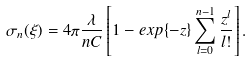Convert formula to latex. <formula><loc_0><loc_0><loc_500><loc_500>\sigma _ { n } ( \xi ) = 4 \pi \frac { \lambda } { n C } \left [ 1 - e x p \{ - z \} \sum _ { l = 0 } ^ { n - 1 } \frac { z ^ { l } } { l ! } \right ] .</formula> 